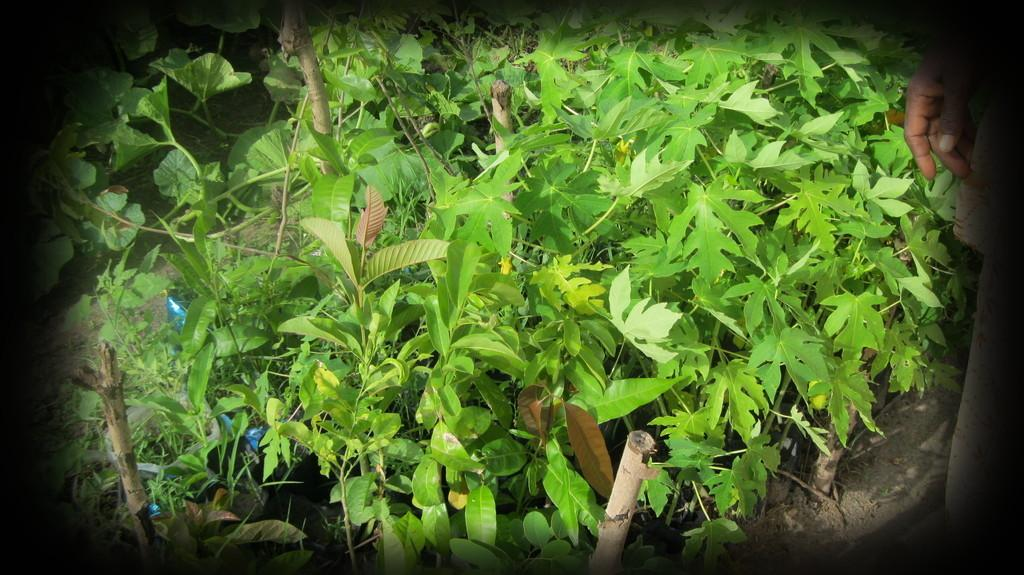What type of living organisms can be seen in the image? Plants can be seen in the image. What objects are made of a rigid material in the image? Sticks are present in the image. Whose hand is visible in the image? A person's hand is visible in the image. What type of hat is the person wearing in the image? There is no hat present in the image; only a person's hand is visible. What type of cracker is being used to feed the plants in the image? There is no cracker present in the image; the plants and sticks are the main subjects. 